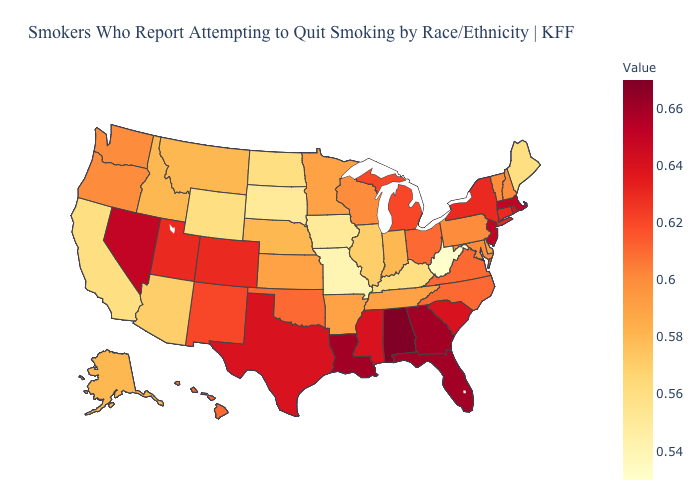Which states have the lowest value in the South?
Answer briefly. West Virginia. Among the states that border Colorado , does Wyoming have the highest value?
Give a very brief answer. No. Which states have the lowest value in the USA?
Short answer required. West Virginia. Which states have the lowest value in the USA?
Be succinct. West Virginia. Which states hav the highest value in the Northeast?
Write a very short answer. Massachusetts, New Jersey. Which states have the lowest value in the USA?
Quick response, please. West Virginia. Among the states that border South Carolina , does North Carolina have the highest value?
Keep it brief. No. Does the map have missing data?
Give a very brief answer. No. 